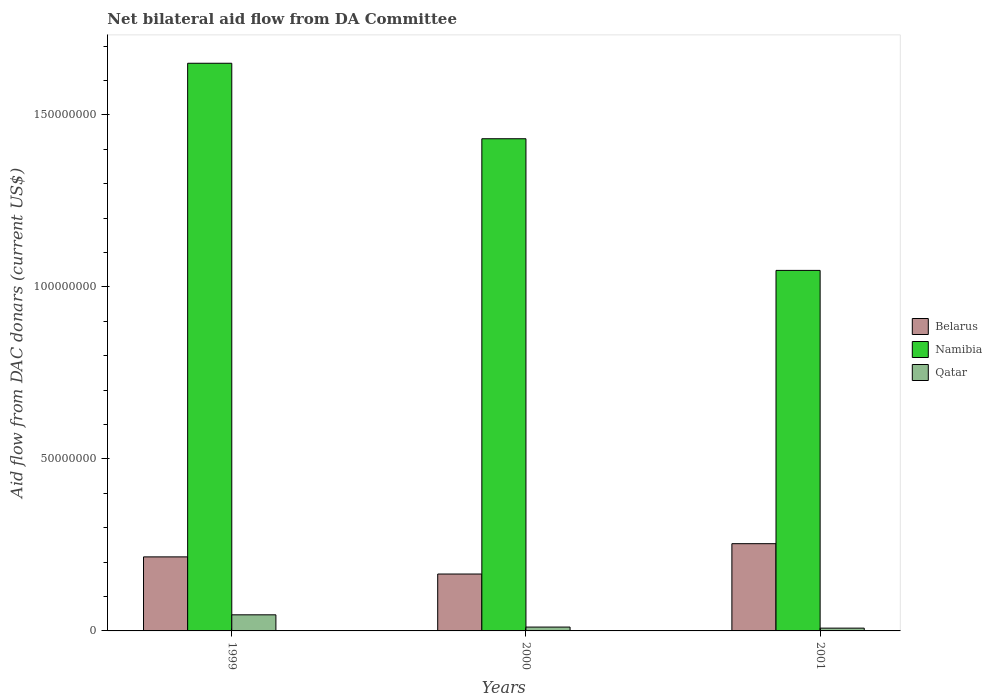How many different coloured bars are there?
Offer a terse response. 3. Are the number of bars per tick equal to the number of legend labels?
Offer a terse response. Yes. Are the number of bars on each tick of the X-axis equal?
Your answer should be compact. Yes. How many bars are there on the 1st tick from the left?
Make the answer very short. 3. How many bars are there on the 1st tick from the right?
Your response must be concise. 3. In how many cases, is the number of bars for a given year not equal to the number of legend labels?
Offer a terse response. 0. What is the aid flow in in Belarus in 1999?
Your answer should be very brief. 2.15e+07. Across all years, what is the maximum aid flow in in Belarus?
Give a very brief answer. 2.54e+07. Across all years, what is the minimum aid flow in in Namibia?
Your response must be concise. 1.05e+08. In which year was the aid flow in in Belarus maximum?
Offer a very short reply. 2001. What is the total aid flow in in Belarus in the graph?
Make the answer very short. 6.34e+07. What is the difference between the aid flow in in Qatar in 2000 and that in 2001?
Give a very brief answer. 3.10e+05. What is the difference between the aid flow in in Belarus in 2001 and the aid flow in in Namibia in 1999?
Keep it short and to the point. -1.40e+08. What is the average aid flow in in Qatar per year?
Provide a succinct answer. 2.20e+06. In the year 2000, what is the difference between the aid flow in in Qatar and aid flow in in Belarus?
Keep it short and to the point. -1.54e+07. In how many years, is the aid flow in in Belarus greater than 10000000 US$?
Your response must be concise. 3. What is the ratio of the aid flow in in Qatar in 1999 to that in 2001?
Your response must be concise. 5.78. Is the aid flow in in Belarus in 1999 less than that in 2001?
Ensure brevity in your answer.  Yes. Is the difference between the aid flow in in Qatar in 1999 and 2001 greater than the difference between the aid flow in in Belarus in 1999 and 2001?
Keep it short and to the point. Yes. What is the difference between the highest and the second highest aid flow in in Belarus?
Your answer should be very brief. 3.84e+06. What is the difference between the highest and the lowest aid flow in in Qatar?
Give a very brief answer. 3.87e+06. Is the sum of the aid flow in in Namibia in 1999 and 2001 greater than the maximum aid flow in in Qatar across all years?
Make the answer very short. Yes. What does the 1st bar from the left in 2000 represents?
Provide a short and direct response. Belarus. What does the 2nd bar from the right in 2001 represents?
Give a very brief answer. Namibia. Is it the case that in every year, the sum of the aid flow in in Namibia and aid flow in in Qatar is greater than the aid flow in in Belarus?
Your answer should be very brief. Yes. How many bars are there?
Provide a succinct answer. 9. Are all the bars in the graph horizontal?
Offer a terse response. No. What is the difference between two consecutive major ticks on the Y-axis?
Your response must be concise. 5.00e+07. Are the values on the major ticks of Y-axis written in scientific E-notation?
Make the answer very short. No. Does the graph contain any zero values?
Ensure brevity in your answer.  No. Does the graph contain grids?
Your answer should be very brief. No. How many legend labels are there?
Give a very brief answer. 3. What is the title of the graph?
Your response must be concise. Net bilateral aid flow from DA Committee. Does "Luxembourg" appear as one of the legend labels in the graph?
Provide a succinct answer. No. What is the label or title of the X-axis?
Provide a succinct answer. Years. What is the label or title of the Y-axis?
Your response must be concise. Aid flow from DAC donars (current US$). What is the Aid flow from DAC donars (current US$) of Belarus in 1999?
Keep it short and to the point. 2.15e+07. What is the Aid flow from DAC donars (current US$) of Namibia in 1999?
Your response must be concise. 1.65e+08. What is the Aid flow from DAC donars (current US$) of Qatar in 1999?
Offer a terse response. 4.68e+06. What is the Aid flow from DAC donars (current US$) of Belarus in 2000?
Provide a succinct answer. 1.65e+07. What is the Aid flow from DAC donars (current US$) in Namibia in 2000?
Provide a short and direct response. 1.43e+08. What is the Aid flow from DAC donars (current US$) of Qatar in 2000?
Your response must be concise. 1.12e+06. What is the Aid flow from DAC donars (current US$) in Belarus in 2001?
Give a very brief answer. 2.54e+07. What is the Aid flow from DAC donars (current US$) in Namibia in 2001?
Offer a very short reply. 1.05e+08. What is the Aid flow from DAC donars (current US$) of Qatar in 2001?
Keep it short and to the point. 8.10e+05. Across all years, what is the maximum Aid flow from DAC donars (current US$) of Belarus?
Make the answer very short. 2.54e+07. Across all years, what is the maximum Aid flow from DAC donars (current US$) in Namibia?
Give a very brief answer. 1.65e+08. Across all years, what is the maximum Aid flow from DAC donars (current US$) in Qatar?
Your answer should be very brief. 4.68e+06. Across all years, what is the minimum Aid flow from DAC donars (current US$) in Belarus?
Your response must be concise. 1.65e+07. Across all years, what is the minimum Aid flow from DAC donars (current US$) in Namibia?
Provide a short and direct response. 1.05e+08. Across all years, what is the minimum Aid flow from DAC donars (current US$) in Qatar?
Provide a succinct answer. 8.10e+05. What is the total Aid flow from DAC donars (current US$) in Belarus in the graph?
Provide a succinct answer. 6.34e+07. What is the total Aid flow from DAC donars (current US$) of Namibia in the graph?
Offer a terse response. 4.13e+08. What is the total Aid flow from DAC donars (current US$) in Qatar in the graph?
Provide a succinct answer. 6.61e+06. What is the difference between the Aid flow from DAC donars (current US$) in Belarus in 1999 and that in 2000?
Offer a terse response. 4.98e+06. What is the difference between the Aid flow from DAC donars (current US$) of Namibia in 1999 and that in 2000?
Keep it short and to the point. 2.19e+07. What is the difference between the Aid flow from DAC donars (current US$) of Qatar in 1999 and that in 2000?
Your response must be concise. 3.56e+06. What is the difference between the Aid flow from DAC donars (current US$) of Belarus in 1999 and that in 2001?
Ensure brevity in your answer.  -3.84e+06. What is the difference between the Aid flow from DAC donars (current US$) in Namibia in 1999 and that in 2001?
Make the answer very short. 6.02e+07. What is the difference between the Aid flow from DAC donars (current US$) of Qatar in 1999 and that in 2001?
Provide a short and direct response. 3.87e+06. What is the difference between the Aid flow from DAC donars (current US$) of Belarus in 2000 and that in 2001?
Offer a terse response. -8.82e+06. What is the difference between the Aid flow from DAC donars (current US$) of Namibia in 2000 and that in 2001?
Your answer should be very brief. 3.83e+07. What is the difference between the Aid flow from DAC donars (current US$) in Qatar in 2000 and that in 2001?
Your answer should be compact. 3.10e+05. What is the difference between the Aid flow from DAC donars (current US$) of Belarus in 1999 and the Aid flow from DAC donars (current US$) of Namibia in 2000?
Ensure brevity in your answer.  -1.22e+08. What is the difference between the Aid flow from DAC donars (current US$) in Belarus in 1999 and the Aid flow from DAC donars (current US$) in Qatar in 2000?
Provide a succinct answer. 2.04e+07. What is the difference between the Aid flow from DAC donars (current US$) of Namibia in 1999 and the Aid flow from DAC donars (current US$) of Qatar in 2000?
Ensure brevity in your answer.  1.64e+08. What is the difference between the Aid flow from DAC donars (current US$) in Belarus in 1999 and the Aid flow from DAC donars (current US$) in Namibia in 2001?
Provide a short and direct response. -8.33e+07. What is the difference between the Aid flow from DAC donars (current US$) in Belarus in 1999 and the Aid flow from DAC donars (current US$) in Qatar in 2001?
Offer a very short reply. 2.07e+07. What is the difference between the Aid flow from DAC donars (current US$) of Namibia in 1999 and the Aid flow from DAC donars (current US$) of Qatar in 2001?
Ensure brevity in your answer.  1.64e+08. What is the difference between the Aid flow from DAC donars (current US$) in Belarus in 2000 and the Aid flow from DAC donars (current US$) in Namibia in 2001?
Keep it short and to the point. -8.82e+07. What is the difference between the Aid flow from DAC donars (current US$) of Belarus in 2000 and the Aid flow from DAC donars (current US$) of Qatar in 2001?
Keep it short and to the point. 1.57e+07. What is the difference between the Aid flow from DAC donars (current US$) in Namibia in 2000 and the Aid flow from DAC donars (current US$) in Qatar in 2001?
Your answer should be very brief. 1.42e+08. What is the average Aid flow from DAC donars (current US$) in Belarus per year?
Ensure brevity in your answer.  2.11e+07. What is the average Aid flow from DAC donars (current US$) of Namibia per year?
Your response must be concise. 1.38e+08. What is the average Aid flow from DAC donars (current US$) in Qatar per year?
Keep it short and to the point. 2.20e+06. In the year 1999, what is the difference between the Aid flow from DAC donars (current US$) in Belarus and Aid flow from DAC donars (current US$) in Namibia?
Give a very brief answer. -1.43e+08. In the year 1999, what is the difference between the Aid flow from DAC donars (current US$) of Belarus and Aid flow from DAC donars (current US$) of Qatar?
Offer a very short reply. 1.68e+07. In the year 1999, what is the difference between the Aid flow from DAC donars (current US$) in Namibia and Aid flow from DAC donars (current US$) in Qatar?
Offer a terse response. 1.60e+08. In the year 2000, what is the difference between the Aid flow from DAC donars (current US$) of Belarus and Aid flow from DAC donars (current US$) of Namibia?
Provide a succinct answer. -1.27e+08. In the year 2000, what is the difference between the Aid flow from DAC donars (current US$) in Belarus and Aid flow from DAC donars (current US$) in Qatar?
Your answer should be compact. 1.54e+07. In the year 2000, what is the difference between the Aid flow from DAC donars (current US$) of Namibia and Aid flow from DAC donars (current US$) of Qatar?
Your answer should be compact. 1.42e+08. In the year 2001, what is the difference between the Aid flow from DAC donars (current US$) of Belarus and Aid flow from DAC donars (current US$) of Namibia?
Provide a succinct answer. -7.94e+07. In the year 2001, what is the difference between the Aid flow from DAC donars (current US$) of Belarus and Aid flow from DAC donars (current US$) of Qatar?
Keep it short and to the point. 2.46e+07. In the year 2001, what is the difference between the Aid flow from DAC donars (current US$) of Namibia and Aid flow from DAC donars (current US$) of Qatar?
Provide a succinct answer. 1.04e+08. What is the ratio of the Aid flow from DAC donars (current US$) of Belarus in 1999 to that in 2000?
Offer a terse response. 1.3. What is the ratio of the Aid flow from DAC donars (current US$) in Namibia in 1999 to that in 2000?
Provide a short and direct response. 1.15. What is the ratio of the Aid flow from DAC donars (current US$) in Qatar in 1999 to that in 2000?
Make the answer very short. 4.18. What is the ratio of the Aid flow from DAC donars (current US$) in Belarus in 1999 to that in 2001?
Provide a short and direct response. 0.85. What is the ratio of the Aid flow from DAC donars (current US$) of Namibia in 1999 to that in 2001?
Your response must be concise. 1.57. What is the ratio of the Aid flow from DAC donars (current US$) of Qatar in 1999 to that in 2001?
Your response must be concise. 5.78. What is the ratio of the Aid flow from DAC donars (current US$) in Belarus in 2000 to that in 2001?
Your answer should be compact. 0.65. What is the ratio of the Aid flow from DAC donars (current US$) of Namibia in 2000 to that in 2001?
Provide a succinct answer. 1.37. What is the ratio of the Aid flow from DAC donars (current US$) in Qatar in 2000 to that in 2001?
Offer a very short reply. 1.38. What is the difference between the highest and the second highest Aid flow from DAC donars (current US$) in Belarus?
Provide a succinct answer. 3.84e+06. What is the difference between the highest and the second highest Aid flow from DAC donars (current US$) of Namibia?
Offer a very short reply. 2.19e+07. What is the difference between the highest and the second highest Aid flow from DAC donars (current US$) of Qatar?
Your answer should be compact. 3.56e+06. What is the difference between the highest and the lowest Aid flow from DAC donars (current US$) of Belarus?
Ensure brevity in your answer.  8.82e+06. What is the difference between the highest and the lowest Aid flow from DAC donars (current US$) of Namibia?
Provide a short and direct response. 6.02e+07. What is the difference between the highest and the lowest Aid flow from DAC donars (current US$) of Qatar?
Your answer should be compact. 3.87e+06. 